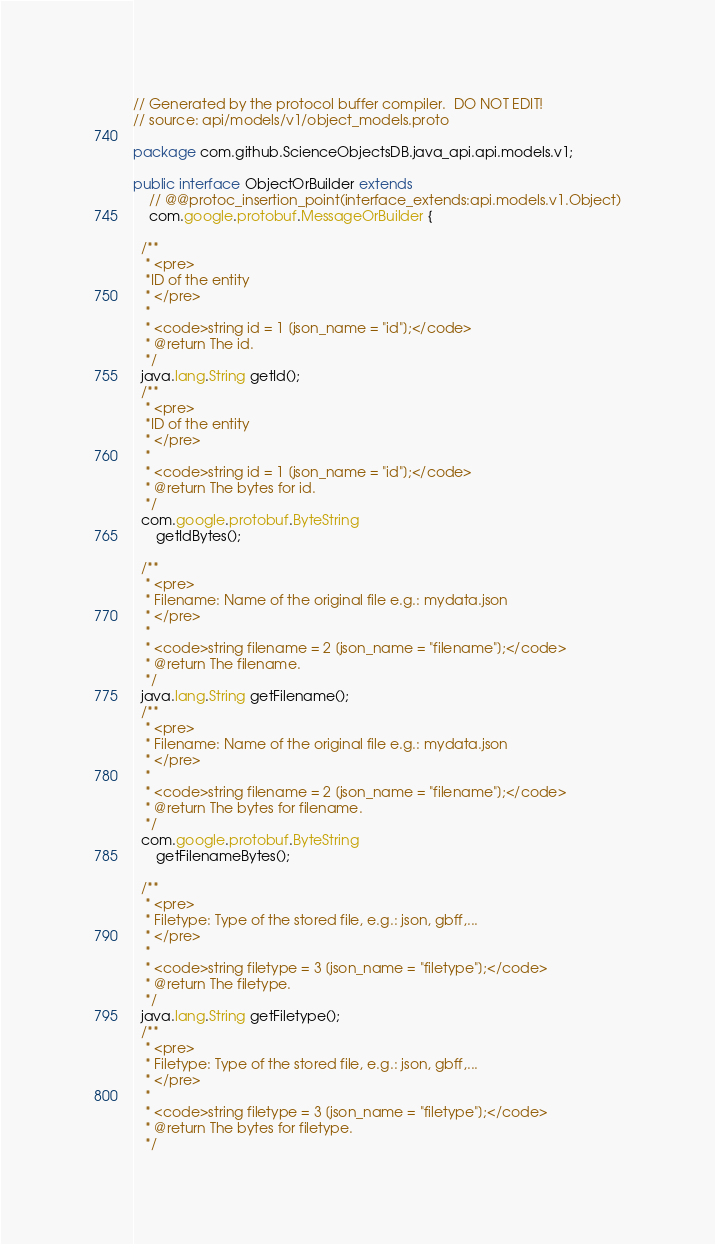Convert code to text. <code><loc_0><loc_0><loc_500><loc_500><_Java_>// Generated by the protocol buffer compiler.  DO NOT EDIT!
// source: api/models/v1/object_models.proto

package com.github.ScienceObjectsDB.java_api.api.models.v1;

public interface ObjectOrBuilder extends
    // @@protoc_insertion_point(interface_extends:api.models.v1.Object)
    com.google.protobuf.MessageOrBuilder {

  /**
   * <pre>
   *ID of the entity
   * </pre>
   *
   * <code>string id = 1 [json_name = "id"];</code>
   * @return The id.
   */
  java.lang.String getId();
  /**
   * <pre>
   *ID of the entity
   * </pre>
   *
   * <code>string id = 1 [json_name = "id"];</code>
   * @return The bytes for id.
   */
  com.google.protobuf.ByteString
      getIdBytes();

  /**
   * <pre>
   * Filename: Name of the original file e.g.: mydata.json
   * </pre>
   *
   * <code>string filename = 2 [json_name = "filename"];</code>
   * @return The filename.
   */
  java.lang.String getFilename();
  /**
   * <pre>
   * Filename: Name of the original file e.g.: mydata.json
   * </pre>
   *
   * <code>string filename = 2 [json_name = "filename"];</code>
   * @return The bytes for filename.
   */
  com.google.protobuf.ByteString
      getFilenameBytes();

  /**
   * <pre>
   * Filetype: Type of the stored file, e.g.: json, gbff,...
   * </pre>
   *
   * <code>string filetype = 3 [json_name = "filetype"];</code>
   * @return The filetype.
   */
  java.lang.String getFiletype();
  /**
   * <pre>
   * Filetype: Type of the stored file, e.g.: json, gbff,...
   * </pre>
   *
   * <code>string filetype = 3 [json_name = "filetype"];</code>
   * @return The bytes for filetype.
   */</code> 